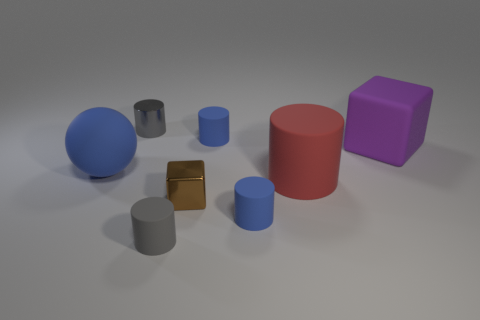Subtract all red cylinders. How many cylinders are left? 4 Subtract all metal cylinders. How many cylinders are left? 4 Subtract all brown cylinders. Subtract all brown cubes. How many cylinders are left? 5 Add 2 tiny blue things. How many objects exist? 10 Subtract all cylinders. How many objects are left? 3 Subtract all rubber objects. Subtract all tiny cyan metallic cylinders. How many objects are left? 2 Add 1 red cylinders. How many red cylinders are left? 2 Add 8 large cyan matte cylinders. How many large cyan matte cylinders exist? 8 Subtract 0 gray blocks. How many objects are left? 8 